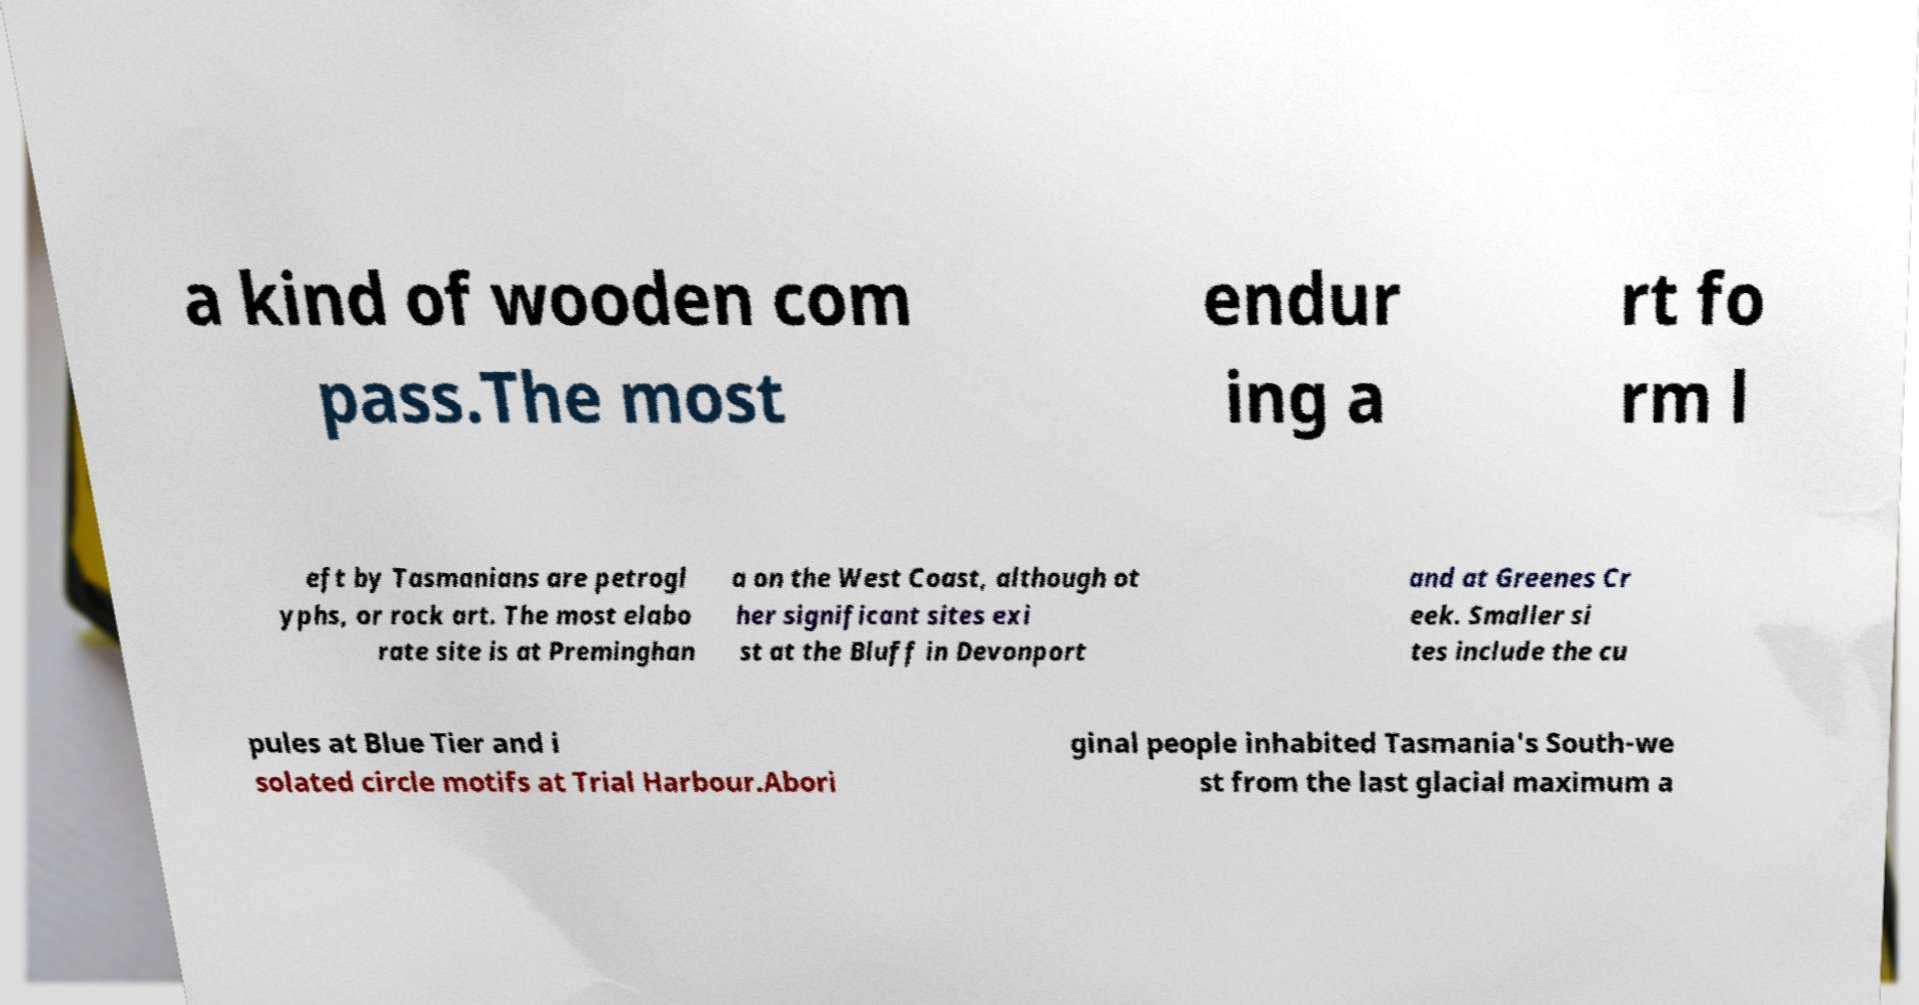Could you extract and type out the text from this image? a kind of wooden com pass.The most endur ing a rt fo rm l eft by Tasmanians are petrogl yphs, or rock art. The most elabo rate site is at Preminghan a on the West Coast, although ot her significant sites exi st at the Bluff in Devonport and at Greenes Cr eek. Smaller si tes include the cu pules at Blue Tier and i solated circle motifs at Trial Harbour.Abori ginal people inhabited Tasmania's South-we st from the last glacial maximum a 